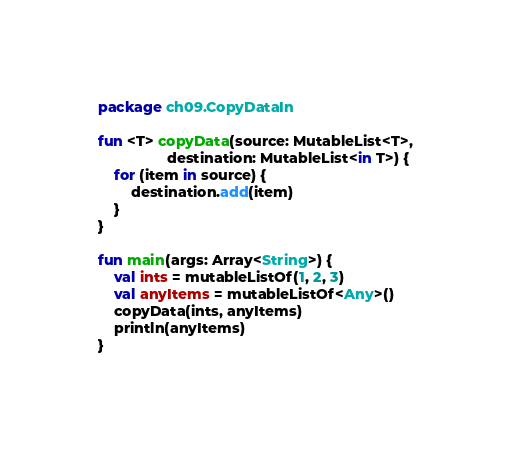Convert code to text. <code><loc_0><loc_0><loc_500><loc_500><_Kotlin_>package ch09.CopyDataIn

fun <T> copyData(source: MutableList<T>,
                 destination: MutableList<in T>) {
    for (item in source) {
        destination.add(item)
    }
}

fun main(args: Array<String>) {
    val ints = mutableListOf(1, 2, 3)
    val anyItems = mutableListOf<Any>()
    copyData(ints, anyItems)
    println(anyItems)
}
</code> 